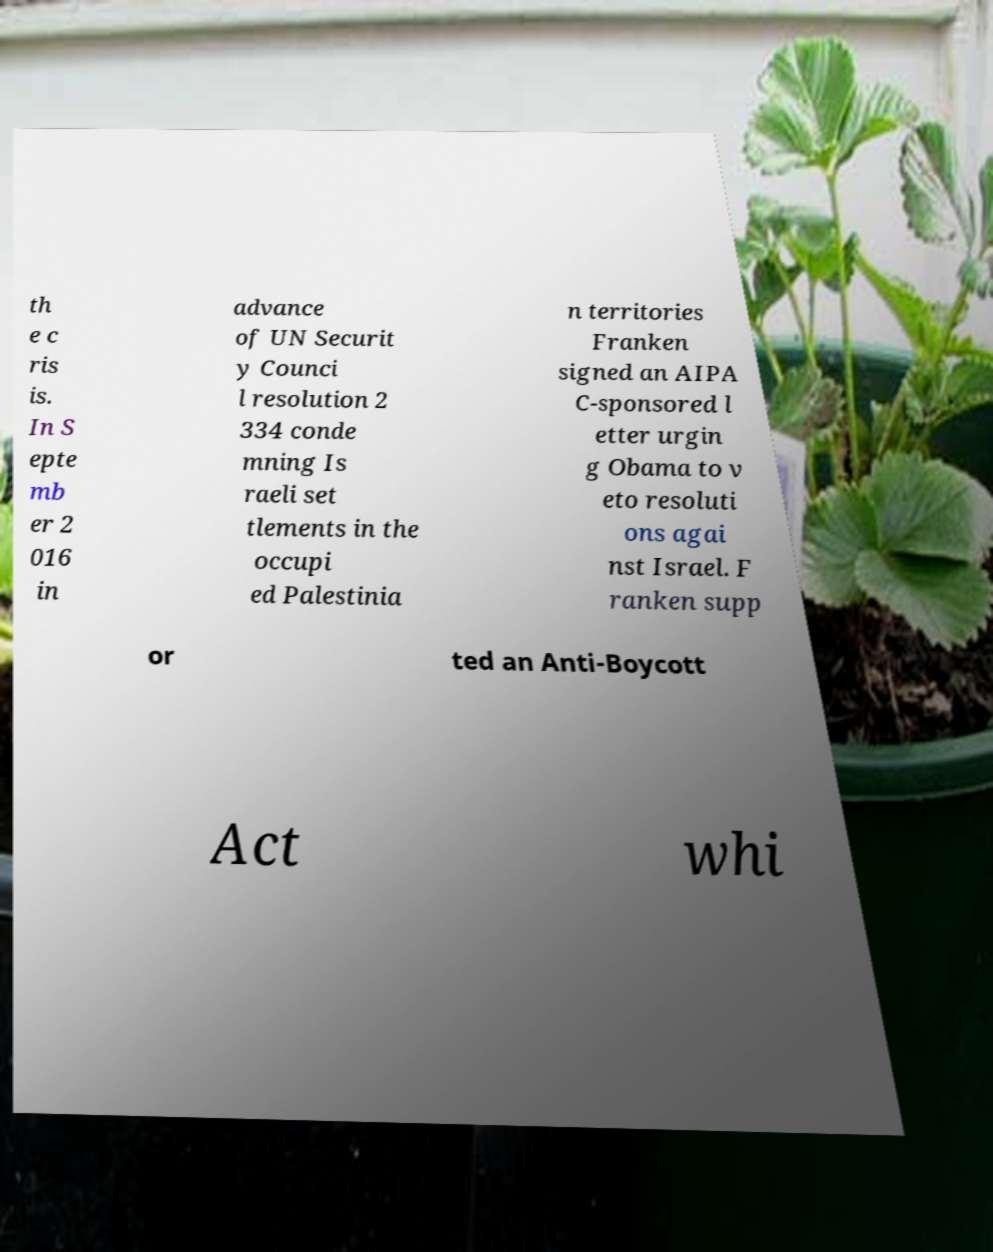What messages or text are displayed in this image? I need them in a readable, typed format. th e c ris is. In S epte mb er 2 016 in advance of UN Securit y Counci l resolution 2 334 conde mning Is raeli set tlements in the occupi ed Palestinia n territories Franken signed an AIPA C-sponsored l etter urgin g Obama to v eto resoluti ons agai nst Israel. F ranken supp or ted an Anti-Boycott Act whi 